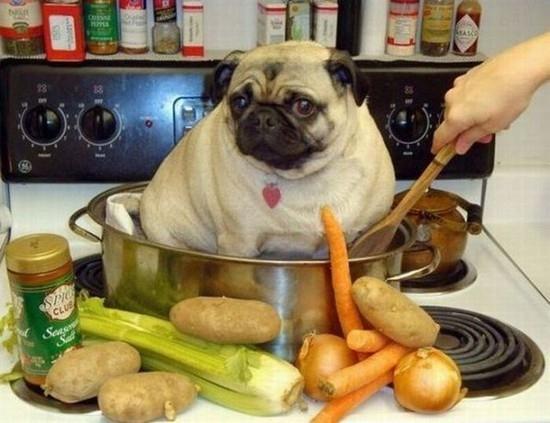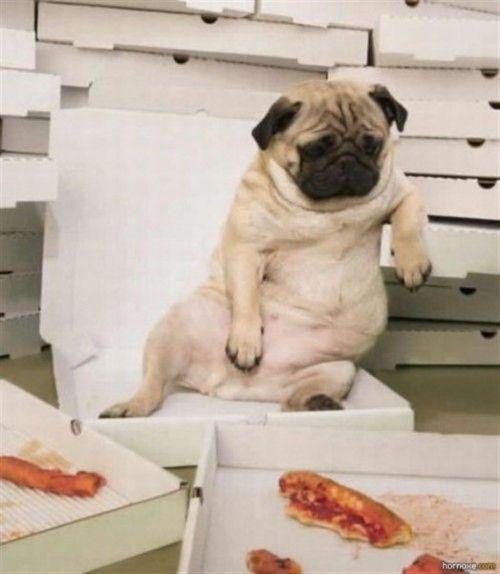The first image is the image on the left, the second image is the image on the right. Analyze the images presented: Is the assertion "There is a pug eating a slice of pizza, and another pug not eating a slice of pizza." valid? Answer yes or no. No. 